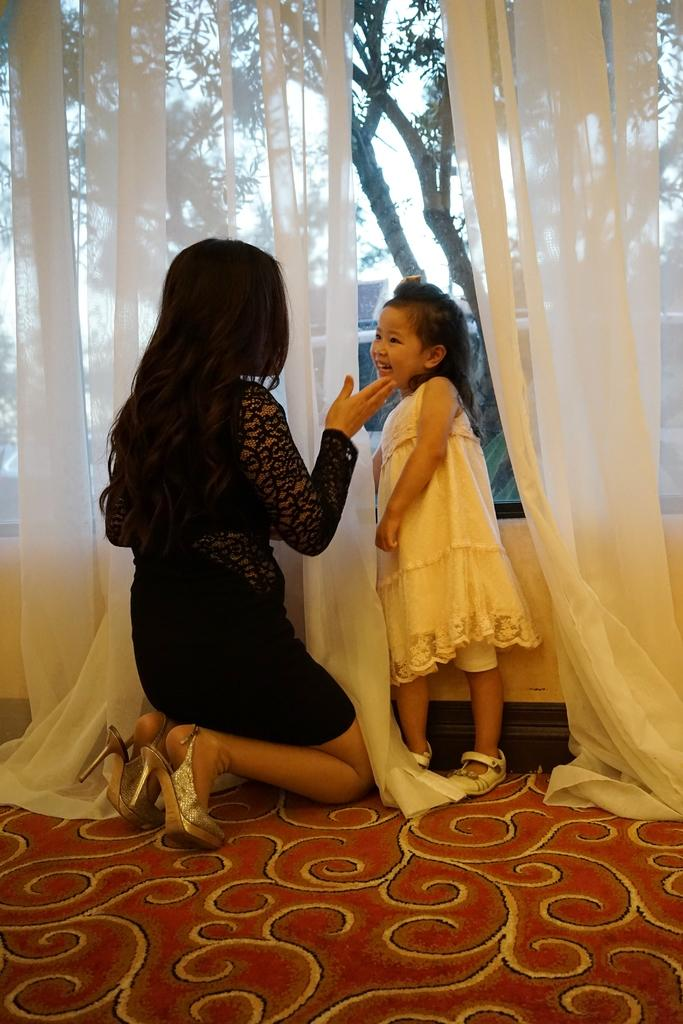What type of window treatment is present in the image? There are white color curtains in the image. What is the woman in the image wearing? The woman is wearing a black color dress in the image. What is the girl in the image wearing? The girl is wearing a white color dress in the image. What type of natural environment can be seen in the image? Trees are visible in the image. What is visible at the top of the image? The sky is visible at the top of the image. How many balls are being juggled by the ant in the image? There are no ants or balls present in the image. What time of day is depicted in the image? The time of day cannot be determined from the image, as there are no specific indicators of time. 